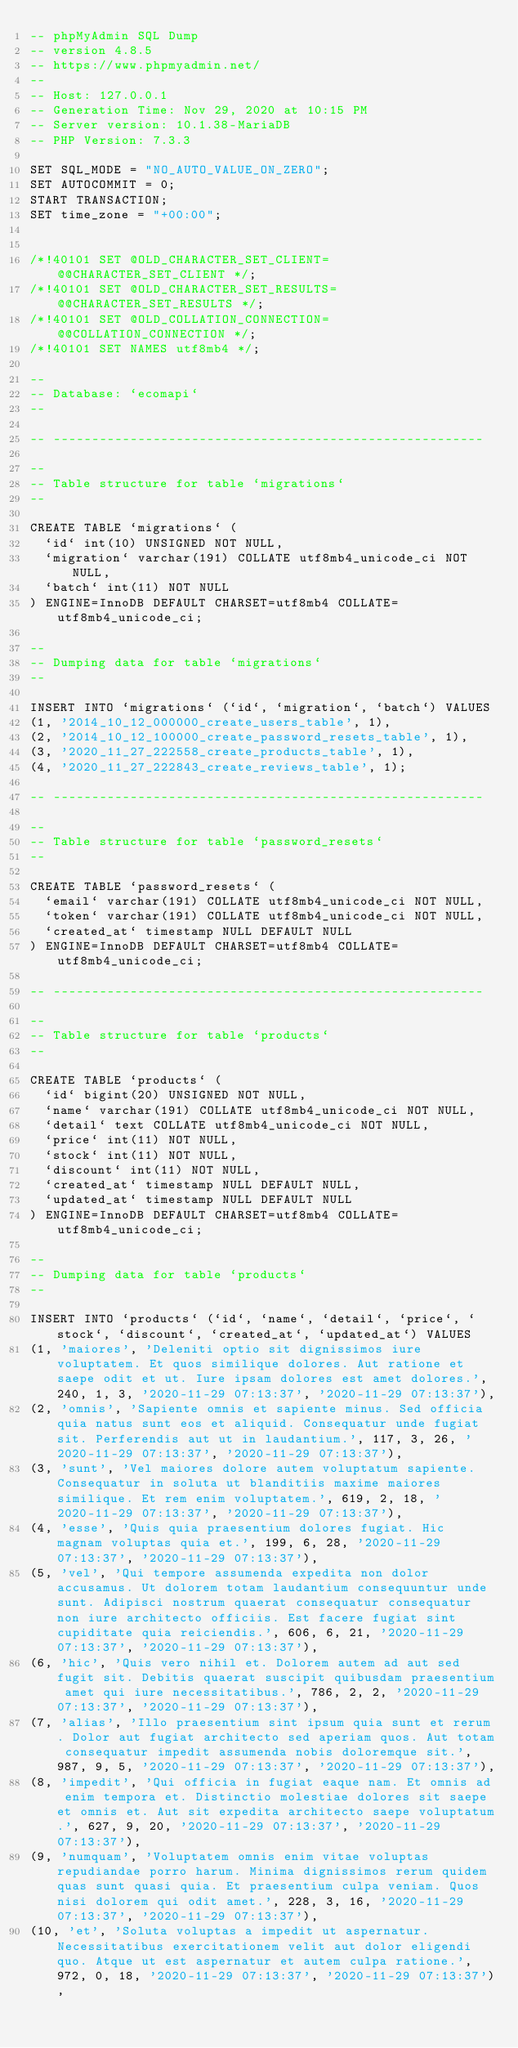<code> <loc_0><loc_0><loc_500><loc_500><_SQL_>-- phpMyAdmin SQL Dump
-- version 4.8.5
-- https://www.phpmyadmin.net/
--
-- Host: 127.0.0.1
-- Generation Time: Nov 29, 2020 at 10:15 PM
-- Server version: 10.1.38-MariaDB
-- PHP Version: 7.3.3

SET SQL_MODE = "NO_AUTO_VALUE_ON_ZERO";
SET AUTOCOMMIT = 0;
START TRANSACTION;
SET time_zone = "+00:00";


/*!40101 SET @OLD_CHARACTER_SET_CLIENT=@@CHARACTER_SET_CLIENT */;
/*!40101 SET @OLD_CHARACTER_SET_RESULTS=@@CHARACTER_SET_RESULTS */;
/*!40101 SET @OLD_COLLATION_CONNECTION=@@COLLATION_CONNECTION */;
/*!40101 SET NAMES utf8mb4 */;

--
-- Database: `ecomapi`
--

-- --------------------------------------------------------

--
-- Table structure for table `migrations`
--

CREATE TABLE `migrations` (
  `id` int(10) UNSIGNED NOT NULL,
  `migration` varchar(191) COLLATE utf8mb4_unicode_ci NOT NULL,
  `batch` int(11) NOT NULL
) ENGINE=InnoDB DEFAULT CHARSET=utf8mb4 COLLATE=utf8mb4_unicode_ci;

--
-- Dumping data for table `migrations`
--

INSERT INTO `migrations` (`id`, `migration`, `batch`) VALUES
(1, '2014_10_12_000000_create_users_table', 1),
(2, '2014_10_12_100000_create_password_resets_table', 1),
(3, '2020_11_27_222558_create_products_table', 1),
(4, '2020_11_27_222843_create_reviews_table', 1);

-- --------------------------------------------------------

--
-- Table structure for table `password_resets`
--

CREATE TABLE `password_resets` (
  `email` varchar(191) COLLATE utf8mb4_unicode_ci NOT NULL,
  `token` varchar(191) COLLATE utf8mb4_unicode_ci NOT NULL,
  `created_at` timestamp NULL DEFAULT NULL
) ENGINE=InnoDB DEFAULT CHARSET=utf8mb4 COLLATE=utf8mb4_unicode_ci;

-- --------------------------------------------------------

--
-- Table structure for table `products`
--

CREATE TABLE `products` (
  `id` bigint(20) UNSIGNED NOT NULL,
  `name` varchar(191) COLLATE utf8mb4_unicode_ci NOT NULL,
  `detail` text COLLATE utf8mb4_unicode_ci NOT NULL,
  `price` int(11) NOT NULL,
  `stock` int(11) NOT NULL,
  `discount` int(11) NOT NULL,
  `created_at` timestamp NULL DEFAULT NULL,
  `updated_at` timestamp NULL DEFAULT NULL
) ENGINE=InnoDB DEFAULT CHARSET=utf8mb4 COLLATE=utf8mb4_unicode_ci;

--
-- Dumping data for table `products`
--

INSERT INTO `products` (`id`, `name`, `detail`, `price`, `stock`, `discount`, `created_at`, `updated_at`) VALUES
(1, 'maiores', 'Deleniti optio sit dignissimos iure voluptatem. Et quos similique dolores. Aut ratione et saepe odit et ut. Iure ipsam dolores est amet dolores.', 240, 1, 3, '2020-11-29 07:13:37', '2020-11-29 07:13:37'),
(2, 'omnis', 'Sapiente omnis et sapiente minus. Sed officia quia natus sunt eos et aliquid. Consequatur unde fugiat sit. Perferendis aut ut in laudantium.', 117, 3, 26, '2020-11-29 07:13:37', '2020-11-29 07:13:37'),
(3, 'sunt', 'Vel maiores dolore autem voluptatum sapiente. Consequatur in soluta ut blanditiis maxime maiores similique. Et rem enim voluptatem.', 619, 2, 18, '2020-11-29 07:13:37', '2020-11-29 07:13:37'),
(4, 'esse', 'Quis quia praesentium dolores fugiat. Hic magnam voluptas quia et.', 199, 6, 28, '2020-11-29 07:13:37', '2020-11-29 07:13:37'),
(5, 'vel', 'Qui tempore assumenda expedita non dolor accusamus. Ut dolorem totam laudantium consequuntur unde sunt. Adipisci nostrum quaerat consequatur consequatur non iure architecto officiis. Est facere fugiat sint cupiditate quia reiciendis.', 606, 6, 21, '2020-11-29 07:13:37', '2020-11-29 07:13:37'),
(6, 'hic', 'Quis vero nihil et. Dolorem autem ad aut sed fugit sit. Debitis quaerat suscipit quibusdam praesentium amet qui iure necessitatibus.', 786, 2, 2, '2020-11-29 07:13:37', '2020-11-29 07:13:37'),
(7, 'alias', 'Illo praesentium sint ipsum quia sunt et rerum. Dolor aut fugiat architecto sed aperiam quos. Aut totam consequatur impedit assumenda nobis doloremque sit.', 987, 9, 5, '2020-11-29 07:13:37', '2020-11-29 07:13:37'),
(8, 'impedit', 'Qui officia in fugiat eaque nam. Et omnis ad enim tempora et. Distinctio molestiae dolores sit saepe et omnis et. Aut sit expedita architecto saepe voluptatum.', 627, 9, 20, '2020-11-29 07:13:37', '2020-11-29 07:13:37'),
(9, 'numquam', 'Voluptatem omnis enim vitae voluptas repudiandae porro harum. Minima dignissimos rerum quidem quas sunt quasi quia. Et praesentium culpa veniam. Quos nisi dolorem qui odit amet.', 228, 3, 16, '2020-11-29 07:13:37', '2020-11-29 07:13:37'),
(10, 'et', 'Soluta voluptas a impedit ut aspernatur. Necessitatibus exercitationem velit aut dolor eligendi quo. Atque ut est aspernatur et autem culpa ratione.', 972, 0, 18, '2020-11-29 07:13:37', '2020-11-29 07:13:37'),</code> 